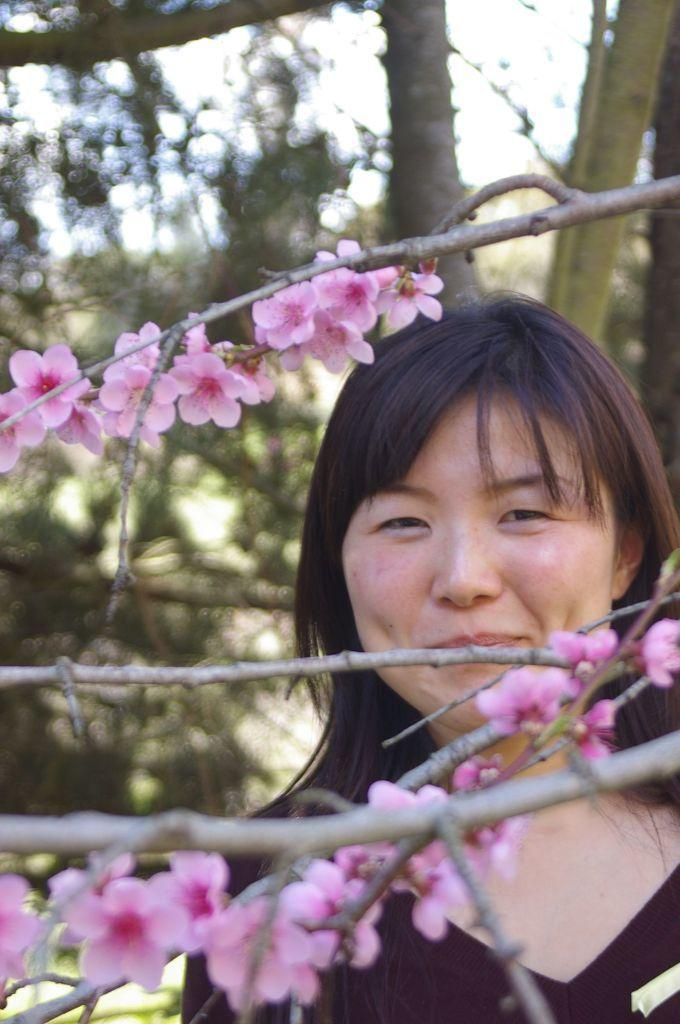What is located in the foreground of the picture? There are flowers and stems in the foreground of the picture. Who or what else can be seen in the foreground of the picture? There is a woman in the foreground of the picture. What can be seen in the background of the picture? There are trees and the sky visible in the background of the picture. How does the woman support the giraffe in the image? There is no giraffe present in the image, so the woman is not supporting any giraffe. What is the rate of the woman's heartbeat in the image? There is no information about the woman's heartbeat in the image, so we cannot determine her heart rate. 